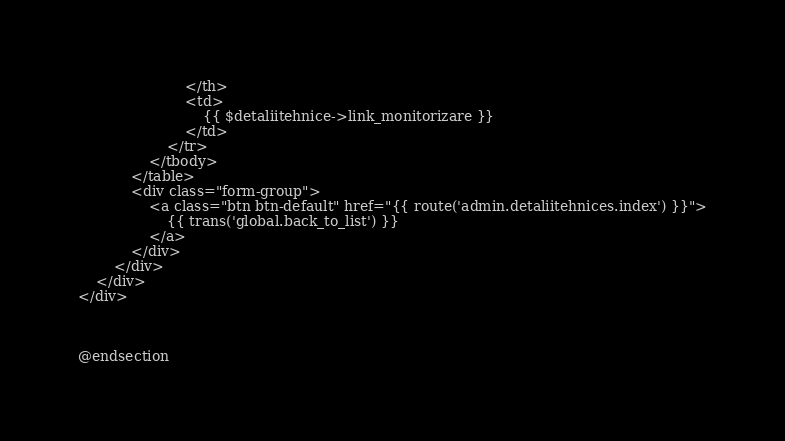<code> <loc_0><loc_0><loc_500><loc_500><_PHP_>                        </th>
                        <td>
                            {{ $detaliitehnice->link_monitorizare }}
                        </td>
                    </tr>
                </tbody>
            </table>
            <div class="form-group">
                <a class="btn btn-default" href="{{ route('admin.detaliitehnices.index') }}">
                    {{ trans('global.back_to_list') }}
                </a>
            </div>
        </div>
    </div>
</div>



@endsection</code> 